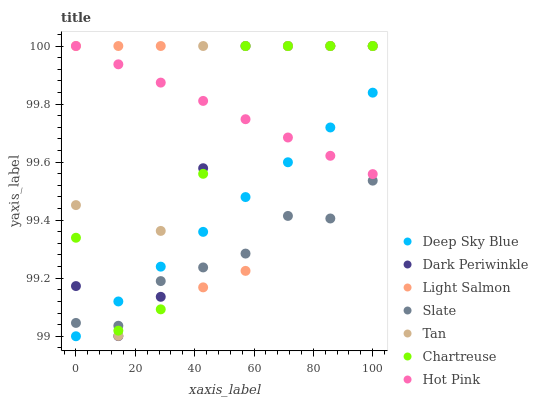Does Slate have the minimum area under the curve?
Answer yes or no. Yes. Does Hot Pink have the maximum area under the curve?
Answer yes or no. Yes. Does Hot Pink have the minimum area under the curve?
Answer yes or no. No. Does Slate have the maximum area under the curve?
Answer yes or no. No. Is Deep Sky Blue the smoothest?
Answer yes or no. Yes. Is Light Salmon the roughest?
Answer yes or no. Yes. Is Slate the smoothest?
Answer yes or no. No. Is Slate the roughest?
Answer yes or no. No. Does Deep Sky Blue have the lowest value?
Answer yes or no. Yes. Does Slate have the lowest value?
Answer yes or no. No. Does Dark Periwinkle have the highest value?
Answer yes or no. Yes. Does Slate have the highest value?
Answer yes or no. No. Is Slate less than Hot Pink?
Answer yes or no. Yes. Is Hot Pink greater than Slate?
Answer yes or no. Yes. Does Tan intersect Chartreuse?
Answer yes or no. Yes. Is Tan less than Chartreuse?
Answer yes or no. No. Is Tan greater than Chartreuse?
Answer yes or no. No. Does Slate intersect Hot Pink?
Answer yes or no. No. 